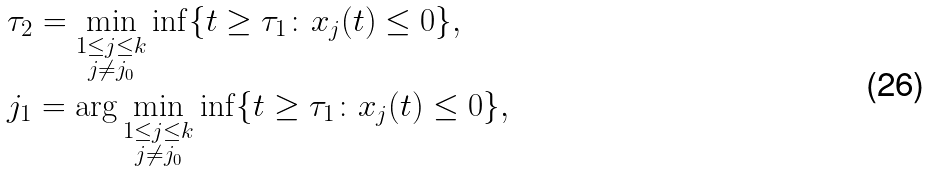Convert formula to latex. <formula><loc_0><loc_0><loc_500><loc_500>& \tau _ { 2 } = \min _ { \substack { 1 \leq j \leq k \\ j \neq j _ { 0 } } } \inf \{ t \geq \tau _ { 1 } \colon x _ { j } ( t ) \leq 0 \} , \\ & j _ { 1 } = \arg \min _ { \substack { 1 \leq j \leq k \\ j \neq j _ { 0 } } } \inf \{ t \geq \tau _ { 1 } \colon x _ { j } ( t ) \leq 0 \} ,</formula> 